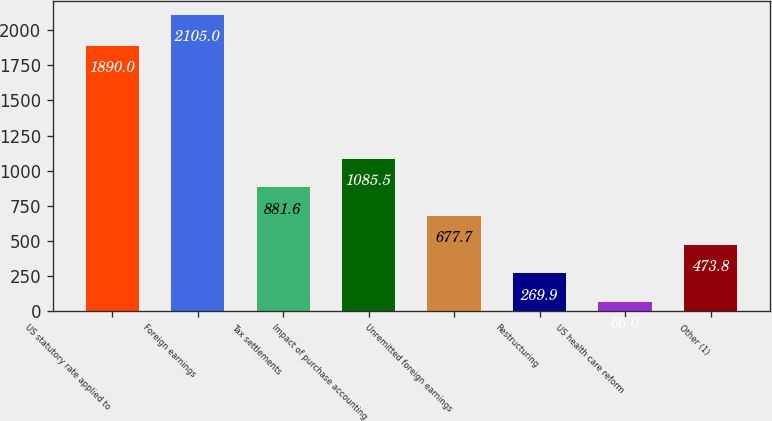<chart> <loc_0><loc_0><loc_500><loc_500><bar_chart><fcel>US statutory rate applied to<fcel>Foreign earnings<fcel>Tax settlements<fcel>Impact of purchase accounting<fcel>Unremitted foreign earnings<fcel>Restructuring<fcel>US health care reform<fcel>Other (1)<nl><fcel>1890<fcel>2105<fcel>881.6<fcel>1085.5<fcel>677.7<fcel>269.9<fcel>66<fcel>473.8<nl></chart> 